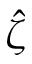Convert formula to latex. <formula><loc_0><loc_0><loc_500><loc_500>\hat { \zeta }</formula> 